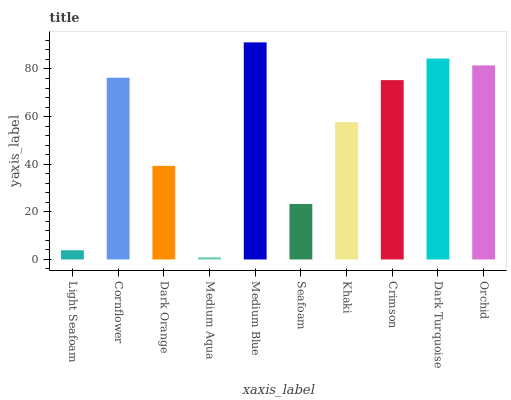Is Medium Aqua the minimum?
Answer yes or no. Yes. Is Medium Blue the maximum?
Answer yes or no. Yes. Is Cornflower the minimum?
Answer yes or no. No. Is Cornflower the maximum?
Answer yes or no. No. Is Cornflower greater than Light Seafoam?
Answer yes or no. Yes. Is Light Seafoam less than Cornflower?
Answer yes or no. Yes. Is Light Seafoam greater than Cornflower?
Answer yes or no. No. Is Cornflower less than Light Seafoam?
Answer yes or no. No. Is Crimson the high median?
Answer yes or no. Yes. Is Khaki the low median?
Answer yes or no. Yes. Is Medium Blue the high median?
Answer yes or no. No. Is Light Seafoam the low median?
Answer yes or no. No. 